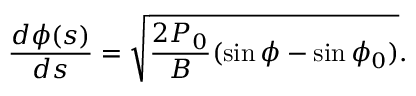<formula> <loc_0><loc_0><loc_500><loc_500>\frac { d \phi ( s ) } { d s } = \sqrt { \frac { 2 P _ { 0 } } { B } ( \sin \phi - \sin \phi _ { 0 } ) } .</formula> 